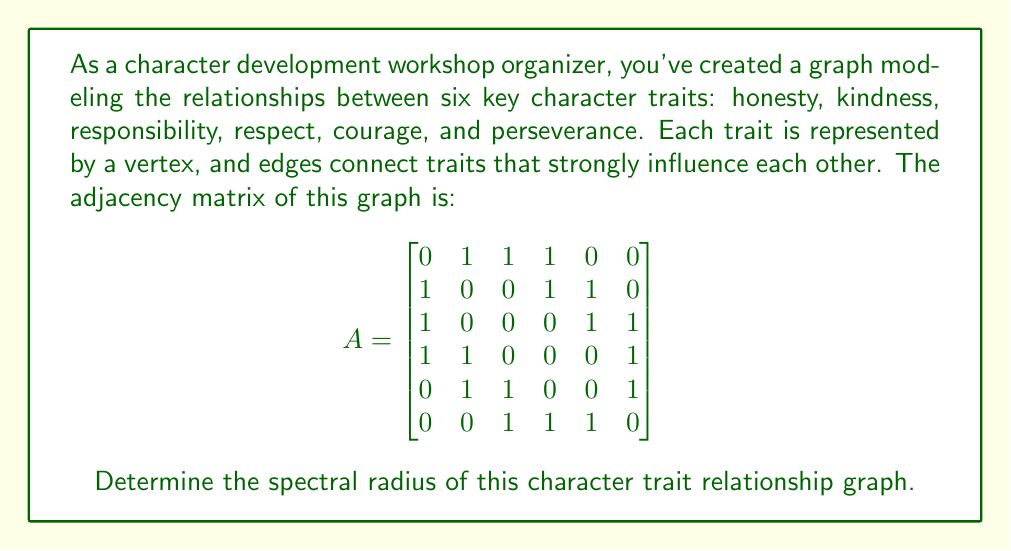Solve this math problem. To find the spectral radius of the graph, we need to follow these steps:

1) The spectral radius is the largest absolute value of the eigenvalues of the adjacency matrix A.

2) To find the eigenvalues, we need to solve the characteristic equation:
   $$\det(A - \lambda I) = 0$$
   where I is the 6x6 identity matrix and λ represents the eigenvalues.

3) Expanding this determinant leads to the characteristic polynomial:
   $$\lambda^6 - 11\lambda^4 - 4\lambda^3 + 18\lambda^2 + 8\lambda - 4 = 0$$

4) This polynomial is difficult to solve by hand, so we can use numerical methods or computer algebra systems to find the roots.

5) The roots (eigenvalues) of this polynomial are approximately:
   $$\lambda_1 \approx 2.4812$$
   $$\lambda_2 \approx -1.8019$$
   $$\lambda_3 \approx 1.2470$$
   $$\lambda_4 \approx -0.9263$$
   $$\lambda_5 \approx 0.5000$$
   $$\lambda_6 \approx -0.5000$$

6) The spectral radius is the largest absolute value among these eigenvalues, which is $|\lambda_1| \approx 2.4812$.

Therefore, the spectral radius of the character trait relationship graph is approximately 2.4812.
Answer: $2.4812$ (rounded to 4 decimal places) 